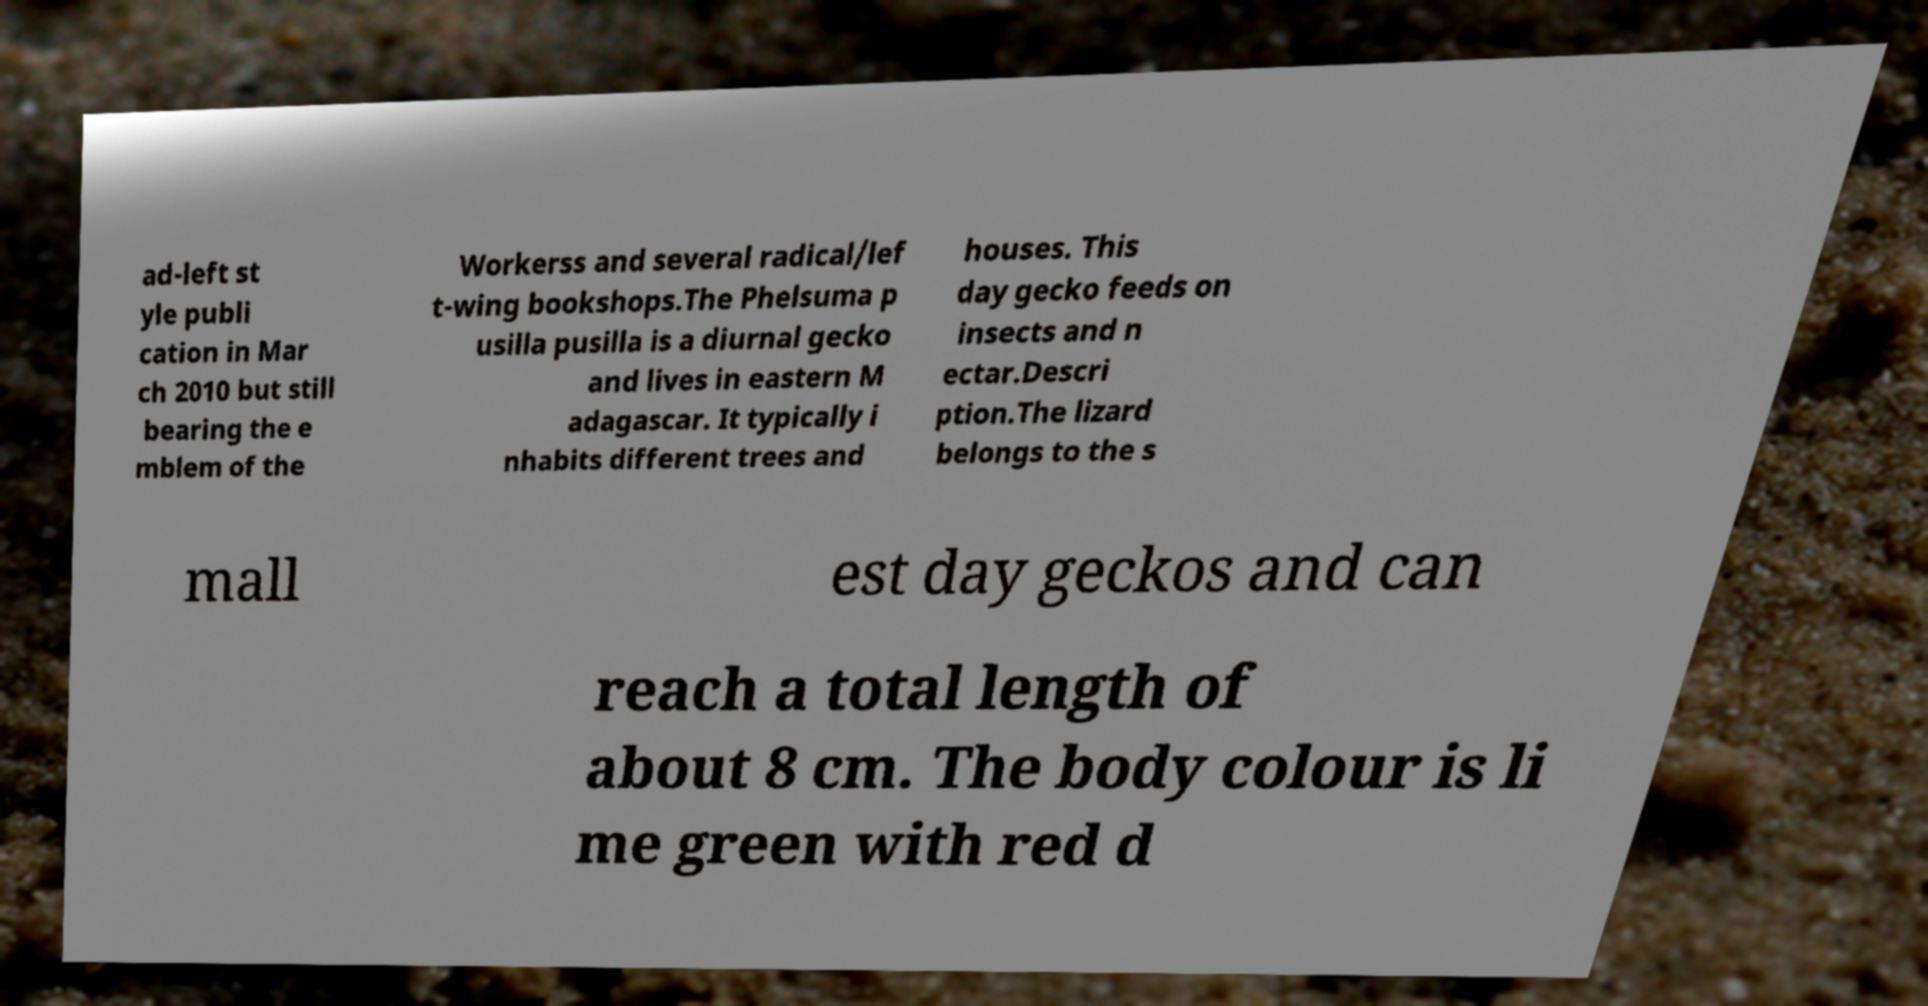Could you assist in decoding the text presented in this image and type it out clearly? ad-left st yle publi cation in Mar ch 2010 but still bearing the e mblem of the Workerss and several radical/lef t-wing bookshops.The Phelsuma p usilla pusilla is a diurnal gecko and lives in eastern M adagascar. It typically i nhabits different trees and houses. This day gecko feeds on insects and n ectar.Descri ption.The lizard belongs to the s mall est day geckos and can reach a total length of about 8 cm. The body colour is li me green with red d 